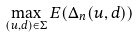<formula> <loc_0><loc_0><loc_500><loc_500>\max _ { ( u , d ) \in \Sigma } E ( \Delta _ { n } ( u , d ) )</formula> 